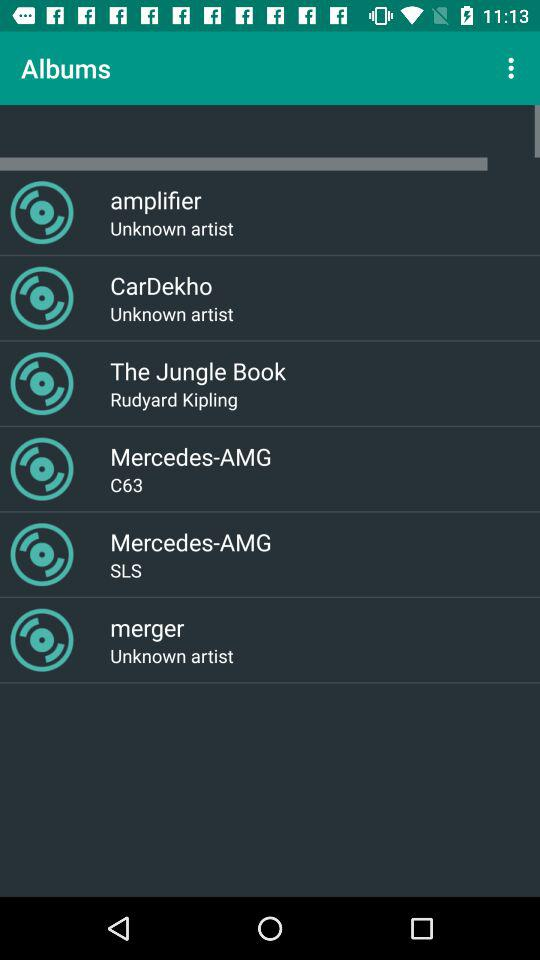How many items have the text 'Unknown artist'?
Answer the question using a single word or phrase. 3 